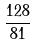<formula> <loc_0><loc_0><loc_500><loc_500>\frac { 1 2 8 } { 8 1 }</formula> 